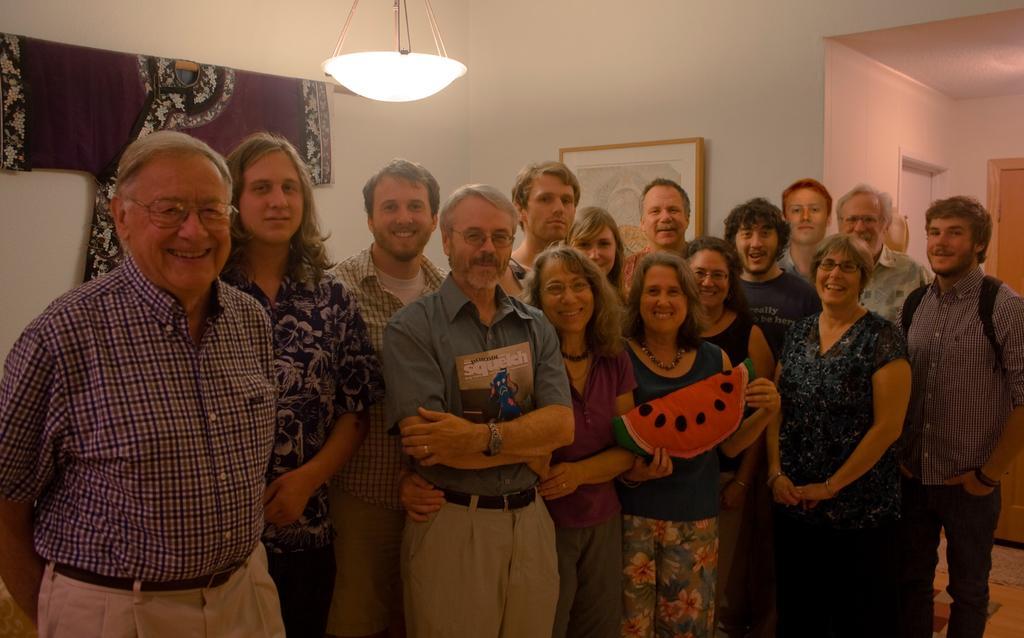Describe this image in one or two sentences. In this image we can see few people standing. There is a person wearing specs and watch. And he is holding a book. There is another lady holding something in the hand. At the top we can see light. There is a photo frame on the wall. And there is a dress hanged on the wall. On the right side there are doors. 